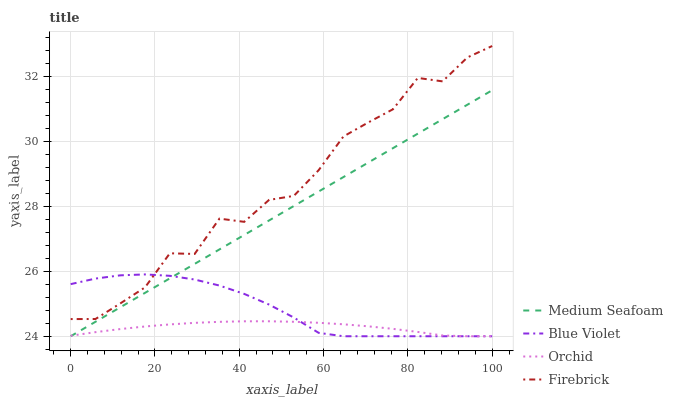Does Medium Seafoam have the minimum area under the curve?
Answer yes or no. No. Does Medium Seafoam have the maximum area under the curve?
Answer yes or no. No. Is Blue Violet the smoothest?
Answer yes or no. No. Is Blue Violet the roughest?
Answer yes or no. No. Does Medium Seafoam have the highest value?
Answer yes or no. No. Is Orchid less than Firebrick?
Answer yes or no. Yes. Is Firebrick greater than Medium Seafoam?
Answer yes or no. Yes. Does Orchid intersect Firebrick?
Answer yes or no. No. 